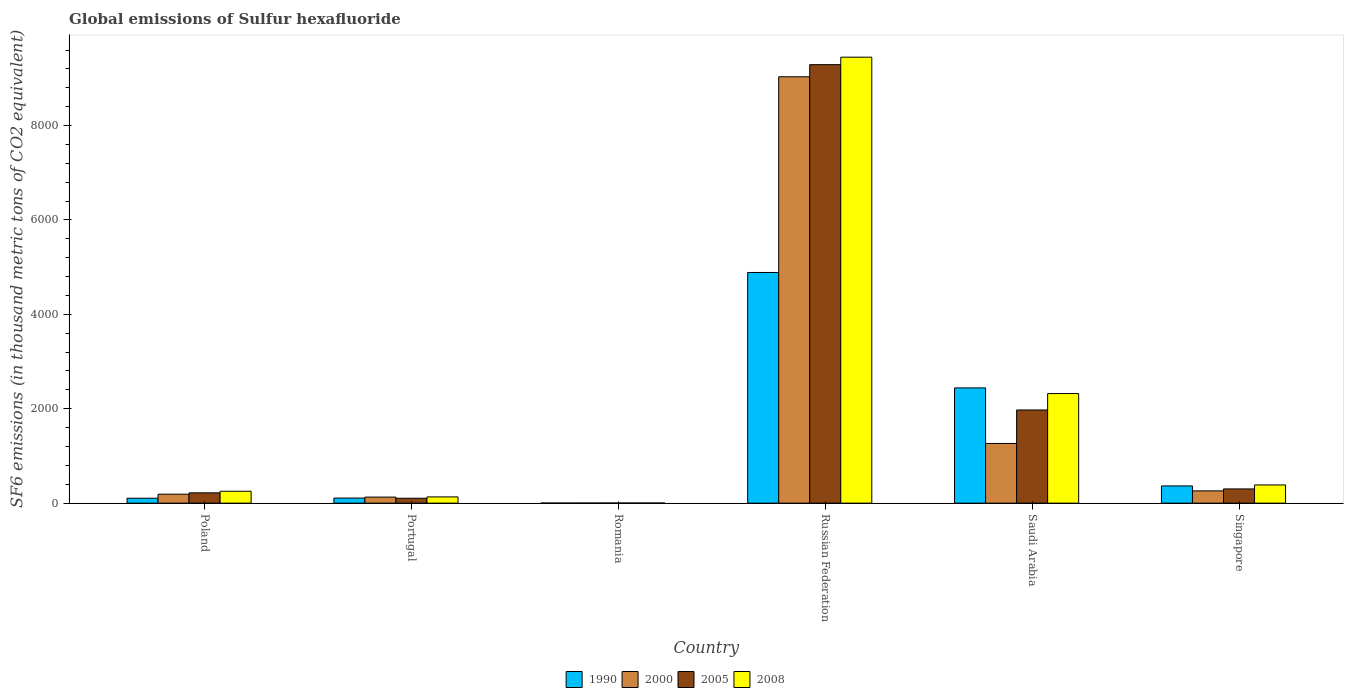How many different coloured bars are there?
Your answer should be very brief. 4. How many groups of bars are there?
Provide a short and direct response. 6. Are the number of bars per tick equal to the number of legend labels?
Ensure brevity in your answer.  Yes. Are the number of bars on each tick of the X-axis equal?
Make the answer very short. Yes. What is the label of the 4th group of bars from the left?
Offer a very short reply. Russian Federation. What is the global emissions of Sulfur hexafluoride in 2008 in Saudi Arabia?
Your response must be concise. 2321.8. Across all countries, what is the maximum global emissions of Sulfur hexafluoride in 1990?
Offer a terse response. 4886.8. In which country was the global emissions of Sulfur hexafluoride in 2008 maximum?
Your answer should be very brief. Russian Federation. In which country was the global emissions of Sulfur hexafluoride in 1990 minimum?
Your response must be concise. Romania. What is the total global emissions of Sulfur hexafluoride in 2008 in the graph?
Your response must be concise. 1.25e+04. What is the difference between the global emissions of Sulfur hexafluoride in 1990 in Poland and that in Romania?
Keep it short and to the point. 102.7. What is the difference between the global emissions of Sulfur hexafluoride in 2005 in Portugal and the global emissions of Sulfur hexafluoride in 1990 in Russian Federation?
Your answer should be compact. -4783. What is the average global emissions of Sulfur hexafluoride in 2005 per country?
Keep it short and to the point. 1981.57. What is the difference between the global emissions of Sulfur hexafluoride of/in 2008 and global emissions of Sulfur hexafluoride of/in 2005 in Poland?
Provide a short and direct response. 33.2. In how many countries, is the global emissions of Sulfur hexafluoride in 2008 greater than 800 thousand metric tons?
Your answer should be very brief. 2. What is the ratio of the global emissions of Sulfur hexafluoride in 2005 in Saudi Arabia to that in Singapore?
Give a very brief answer. 6.55. Is the global emissions of Sulfur hexafluoride in 2008 in Portugal less than that in Romania?
Your response must be concise. No. What is the difference between the highest and the second highest global emissions of Sulfur hexafluoride in 2000?
Keep it short and to the point. -7768.6. What is the difference between the highest and the lowest global emissions of Sulfur hexafluoride in 2008?
Make the answer very short. 9445.9. What does the 1st bar from the left in Romania represents?
Ensure brevity in your answer.  1990. What does the 4th bar from the right in Portugal represents?
Provide a succinct answer. 1990. Is it the case that in every country, the sum of the global emissions of Sulfur hexafluoride in 2008 and global emissions of Sulfur hexafluoride in 2000 is greater than the global emissions of Sulfur hexafluoride in 2005?
Offer a very short reply. Yes. How many bars are there?
Offer a terse response. 24. How many countries are there in the graph?
Give a very brief answer. 6. Does the graph contain any zero values?
Offer a very short reply. No. Where does the legend appear in the graph?
Offer a very short reply. Bottom center. How many legend labels are there?
Your answer should be very brief. 4. What is the title of the graph?
Give a very brief answer. Global emissions of Sulfur hexafluoride. Does "1996" appear as one of the legend labels in the graph?
Your answer should be very brief. No. What is the label or title of the X-axis?
Your response must be concise. Country. What is the label or title of the Y-axis?
Your answer should be compact. SF6 emissions (in thousand metric tons of CO2 equivalent). What is the SF6 emissions (in thousand metric tons of CO2 equivalent) of 1990 in Poland?
Offer a very short reply. 104.3. What is the SF6 emissions (in thousand metric tons of CO2 equivalent) of 2000 in Poland?
Your response must be concise. 189.8. What is the SF6 emissions (in thousand metric tons of CO2 equivalent) in 2005 in Poland?
Keep it short and to the point. 218.5. What is the SF6 emissions (in thousand metric tons of CO2 equivalent) in 2008 in Poland?
Provide a succinct answer. 251.7. What is the SF6 emissions (in thousand metric tons of CO2 equivalent) in 1990 in Portugal?
Your response must be concise. 108. What is the SF6 emissions (in thousand metric tons of CO2 equivalent) in 2000 in Portugal?
Offer a terse response. 128. What is the SF6 emissions (in thousand metric tons of CO2 equivalent) of 2005 in Portugal?
Your answer should be very brief. 103.8. What is the SF6 emissions (in thousand metric tons of CO2 equivalent) in 2008 in Portugal?
Make the answer very short. 132.4. What is the SF6 emissions (in thousand metric tons of CO2 equivalent) of 2000 in Romania?
Offer a very short reply. 2. What is the SF6 emissions (in thousand metric tons of CO2 equivalent) in 2005 in Romania?
Your response must be concise. 2.2. What is the SF6 emissions (in thousand metric tons of CO2 equivalent) in 1990 in Russian Federation?
Your answer should be very brief. 4886.8. What is the SF6 emissions (in thousand metric tons of CO2 equivalent) of 2000 in Russian Federation?
Provide a succinct answer. 9033.2. What is the SF6 emissions (in thousand metric tons of CO2 equivalent) of 2005 in Russian Federation?
Keep it short and to the point. 9289.9. What is the SF6 emissions (in thousand metric tons of CO2 equivalent) of 2008 in Russian Federation?
Your answer should be very brief. 9448.2. What is the SF6 emissions (in thousand metric tons of CO2 equivalent) of 1990 in Saudi Arabia?
Offer a very short reply. 2441.3. What is the SF6 emissions (in thousand metric tons of CO2 equivalent) of 2000 in Saudi Arabia?
Your answer should be compact. 1264.6. What is the SF6 emissions (in thousand metric tons of CO2 equivalent) in 2005 in Saudi Arabia?
Provide a succinct answer. 1973.8. What is the SF6 emissions (in thousand metric tons of CO2 equivalent) of 2008 in Saudi Arabia?
Your answer should be very brief. 2321.8. What is the SF6 emissions (in thousand metric tons of CO2 equivalent) of 1990 in Singapore?
Give a very brief answer. 364.7. What is the SF6 emissions (in thousand metric tons of CO2 equivalent) of 2000 in Singapore?
Provide a short and direct response. 259.8. What is the SF6 emissions (in thousand metric tons of CO2 equivalent) of 2005 in Singapore?
Provide a succinct answer. 301.2. What is the SF6 emissions (in thousand metric tons of CO2 equivalent) in 2008 in Singapore?
Ensure brevity in your answer.  385.5. Across all countries, what is the maximum SF6 emissions (in thousand metric tons of CO2 equivalent) of 1990?
Your answer should be compact. 4886.8. Across all countries, what is the maximum SF6 emissions (in thousand metric tons of CO2 equivalent) in 2000?
Your response must be concise. 9033.2. Across all countries, what is the maximum SF6 emissions (in thousand metric tons of CO2 equivalent) in 2005?
Give a very brief answer. 9289.9. Across all countries, what is the maximum SF6 emissions (in thousand metric tons of CO2 equivalent) of 2008?
Your response must be concise. 9448.2. Across all countries, what is the minimum SF6 emissions (in thousand metric tons of CO2 equivalent) in 1990?
Provide a succinct answer. 1.6. Across all countries, what is the minimum SF6 emissions (in thousand metric tons of CO2 equivalent) of 2005?
Offer a very short reply. 2.2. What is the total SF6 emissions (in thousand metric tons of CO2 equivalent) in 1990 in the graph?
Offer a very short reply. 7906.7. What is the total SF6 emissions (in thousand metric tons of CO2 equivalent) in 2000 in the graph?
Make the answer very short. 1.09e+04. What is the total SF6 emissions (in thousand metric tons of CO2 equivalent) in 2005 in the graph?
Offer a very short reply. 1.19e+04. What is the total SF6 emissions (in thousand metric tons of CO2 equivalent) of 2008 in the graph?
Offer a terse response. 1.25e+04. What is the difference between the SF6 emissions (in thousand metric tons of CO2 equivalent) of 1990 in Poland and that in Portugal?
Your answer should be very brief. -3.7. What is the difference between the SF6 emissions (in thousand metric tons of CO2 equivalent) in 2000 in Poland and that in Portugal?
Offer a very short reply. 61.8. What is the difference between the SF6 emissions (in thousand metric tons of CO2 equivalent) of 2005 in Poland and that in Portugal?
Make the answer very short. 114.7. What is the difference between the SF6 emissions (in thousand metric tons of CO2 equivalent) in 2008 in Poland and that in Portugal?
Give a very brief answer. 119.3. What is the difference between the SF6 emissions (in thousand metric tons of CO2 equivalent) of 1990 in Poland and that in Romania?
Offer a terse response. 102.7. What is the difference between the SF6 emissions (in thousand metric tons of CO2 equivalent) in 2000 in Poland and that in Romania?
Your answer should be compact. 187.8. What is the difference between the SF6 emissions (in thousand metric tons of CO2 equivalent) in 2005 in Poland and that in Romania?
Make the answer very short. 216.3. What is the difference between the SF6 emissions (in thousand metric tons of CO2 equivalent) in 2008 in Poland and that in Romania?
Your answer should be very brief. 249.4. What is the difference between the SF6 emissions (in thousand metric tons of CO2 equivalent) of 1990 in Poland and that in Russian Federation?
Give a very brief answer. -4782.5. What is the difference between the SF6 emissions (in thousand metric tons of CO2 equivalent) of 2000 in Poland and that in Russian Federation?
Provide a short and direct response. -8843.4. What is the difference between the SF6 emissions (in thousand metric tons of CO2 equivalent) of 2005 in Poland and that in Russian Federation?
Make the answer very short. -9071.4. What is the difference between the SF6 emissions (in thousand metric tons of CO2 equivalent) in 2008 in Poland and that in Russian Federation?
Ensure brevity in your answer.  -9196.5. What is the difference between the SF6 emissions (in thousand metric tons of CO2 equivalent) of 1990 in Poland and that in Saudi Arabia?
Ensure brevity in your answer.  -2337. What is the difference between the SF6 emissions (in thousand metric tons of CO2 equivalent) in 2000 in Poland and that in Saudi Arabia?
Your response must be concise. -1074.8. What is the difference between the SF6 emissions (in thousand metric tons of CO2 equivalent) of 2005 in Poland and that in Saudi Arabia?
Offer a terse response. -1755.3. What is the difference between the SF6 emissions (in thousand metric tons of CO2 equivalent) of 2008 in Poland and that in Saudi Arabia?
Keep it short and to the point. -2070.1. What is the difference between the SF6 emissions (in thousand metric tons of CO2 equivalent) in 1990 in Poland and that in Singapore?
Your response must be concise. -260.4. What is the difference between the SF6 emissions (in thousand metric tons of CO2 equivalent) of 2000 in Poland and that in Singapore?
Your answer should be very brief. -70. What is the difference between the SF6 emissions (in thousand metric tons of CO2 equivalent) of 2005 in Poland and that in Singapore?
Your response must be concise. -82.7. What is the difference between the SF6 emissions (in thousand metric tons of CO2 equivalent) in 2008 in Poland and that in Singapore?
Ensure brevity in your answer.  -133.8. What is the difference between the SF6 emissions (in thousand metric tons of CO2 equivalent) of 1990 in Portugal and that in Romania?
Provide a succinct answer. 106.4. What is the difference between the SF6 emissions (in thousand metric tons of CO2 equivalent) in 2000 in Portugal and that in Romania?
Provide a short and direct response. 126. What is the difference between the SF6 emissions (in thousand metric tons of CO2 equivalent) in 2005 in Portugal and that in Romania?
Keep it short and to the point. 101.6. What is the difference between the SF6 emissions (in thousand metric tons of CO2 equivalent) of 2008 in Portugal and that in Romania?
Offer a very short reply. 130.1. What is the difference between the SF6 emissions (in thousand metric tons of CO2 equivalent) in 1990 in Portugal and that in Russian Federation?
Ensure brevity in your answer.  -4778.8. What is the difference between the SF6 emissions (in thousand metric tons of CO2 equivalent) of 2000 in Portugal and that in Russian Federation?
Ensure brevity in your answer.  -8905.2. What is the difference between the SF6 emissions (in thousand metric tons of CO2 equivalent) of 2005 in Portugal and that in Russian Federation?
Provide a short and direct response. -9186.1. What is the difference between the SF6 emissions (in thousand metric tons of CO2 equivalent) of 2008 in Portugal and that in Russian Federation?
Ensure brevity in your answer.  -9315.8. What is the difference between the SF6 emissions (in thousand metric tons of CO2 equivalent) in 1990 in Portugal and that in Saudi Arabia?
Offer a very short reply. -2333.3. What is the difference between the SF6 emissions (in thousand metric tons of CO2 equivalent) in 2000 in Portugal and that in Saudi Arabia?
Give a very brief answer. -1136.6. What is the difference between the SF6 emissions (in thousand metric tons of CO2 equivalent) in 2005 in Portugal and that in Saudi Arabia?
Make the answer very short. -1870. What is the difference between the SF6 emissions (in thousand metric tons of CO2 equivalent) of 2008 in Portugal and that in Saudi Arabia?
Offer a very short reply. -2189.4. What is the difference between the SF6 emissions (in thousand metric tons of CO2 equivalent) in 1990 in Portugal and that in Singapore?
Your answer should be very brief. -256.7. What is the difference between the SF6 emissions (in thousand metric tons of CO2 equivalent) of 2000 in Portugal and that in Singapore?
Your response must be concise. -131.8. What is the difference between the SF6 emissions (in thousand metric tons of CO2 equivalent) of 2005 in Portugal and that in Singapore?
Provide a short and direct response. -197.4. What is the difference between the SF6 emissions (in thousand metric tons of CO2 equivalent) of 2008 in Portugal and that in Singapore?
Keep it short and to the point. -253.1. What is the difference between the SF6 emissions (in thousand metric tons of CO2 equivalent) in 1990 in Romania and that in Russian Federation?
Provide a succinct answer. -4885.2. What is the difference between the SF6 emissions (in thousand metric tons of CO2 equivalent) in 2000 in Romania and that in Russian Federation?
Provide a succinct answer. -9031.2. What is the difference between the SF6 emissions (in thousand metric tons of CO2 equivalent) in 2005 in Romania and that in Russian Federation?
Provide a short and direct response. -9287.7. What is the difference between the SF6 emissions (in thousand metric tons of CO2 equivalent) of 2008 in Romania and that in Russian Federation?
Offer a terse response. -9445.9. What is the difference between the SF6 emissions (in thousand metric tons of CO2 equivalent) in 1990 in Romania and that in Saudi Arabia?
Make the answer very short. -2439.7. What is the difference between the SF6 emissions (in thousand metric tons of CO2 equivalent) of 2000 in Romania and that in Saudi Arabia?
Give a very brief answer. -1262.6. What is the difference between the SF6 emissions (in thousand metric tons of CO2 equivalent) of 2005 in Romania and that in Saudi Arabia?
Your answer should be very brief. -1971.6. What is the difference between the SF6 emissions (in thousand metric tons of CO2 equivalent) in 2008 in Romania and that in Saudi Arabia?
Offer a terse response. -2319.5. What is the difference between the SF6 emissions (in thousand metric tons of CO2 equivalent) in 1990 in Romania and that in Singapore?
Your answer should be compact. -363.1. What is the difference between the SF6 emissions (in thousand metric tons of CO2 equivalent) in 2000 in Romania and that in Singapore?
Provide a succinct answer. -257.8. What is the difference between the SF6 emissions (in thousand metric tons of CO2 equivalent) of 2005 in Romania and that in Singapore?
Provide a short and direct response. -299. What is the difference between the SF6 emissions (in thousand metric tons of CO2 equivalent) of 2008 in Romania and that in Singapore?
Ensure brevity in your answer.  -383.2. What is the difference between the SF6 emissions (in thousand metric tons of CO2 equivalent) of 1990 in Russian Federation and that in Saudi Arabia?
Your answer should be very brief. 2445.5. What is the difference between the SF6 emissions (in thousand metric tons of CO2 equivalent) of 2000 in Russian Federation and that in Saudi Arabia?
Ensure brevity in your answer.  7768.6. What is the difference between the SF6 emissions (in thousand metric tons of CO2 equivalent) of 2005 in Russian Federation and that in Saudi Arabia?
Offer a terse response. 7316.1. What is the difference between the SF6 emissions (in thousand metric tons of CO2 equivalent) in 2008 in Russian Federation and that in Saudi Arabia?
Provide a succinct answer. 7126.4. What is the difference between the SF6 emissions (in thousand metric tons of CO2 equivalent) in 1990 in Russian Federation and that in Singapore?
Provide a short and direct response. 4522.1. What is the difference between the SF6 emissions (in thousand metric tons of CO2 equivalent) of 2000 in Russian Federation and that in Singapore?
Make the answer very short. 8773.4. What is the difference between the SF6 emissions (in thousand metric tons of CO2 equivalent) in 2005 in Russian Federation and that in Singapore?
Ensure brevity in your answer.  8988.7. What is the difference between the SF6 emissions (in thousand metric tons of CO2 equivalent) in 2008 in Russian Federation and that in Singapore?
Offer a terse response. 9062.7. What is the difference between the SF6 emissions (in thousand metric tons of CO2 equivalent) of 1990 in Saudi Arabia and that in Singapore?
Provide a short and direct response. 2076.6. What is the difference between the SF6 emissions (in thousand metric tons of CO2 equivalent) of 2000 in Saudi Arabia and that in Singapore?
Offer a terse response. 1004.8. What is the difference between the SF6 emissions (in thousand metric tons of CO2 equivalent) in 2005 in Saudi Arabia and that in Singapore?
Your response must be concise. 1672.6. What is the difference between the SF6 emissions (in thousand metric tons of CO2 equivalent) of 2008 in Saudi Arabia and that in Singapore?
Provide a short and direct response. 1936.3. What is the difference between the SF6 emissions (in thousand metric tons of CO2 equivalent) in 1990 in Poland and the SF6 emissions (in thousand metric tons of CO2 equivalent) in 2000 in Portugal?
Offer a very short reply. -23.7. What is the difference between the SF6 emissions (in thousand metric tons of CO2 equivalent) in 1990 in Poland and the SF6 emissions (in thousand metric tons of CO2 equivalent) in 2005 in Portugal?
Make the answer very short. 0.5. What is the difference between the SF6 emissions (in thousand metric tons of CO2 equivalent) in 1990 in Poland and the SF6 emissions (in thousand metric tons of CO2 equivalent) in 2008 in Portugal?
Ensure brevity in your answer.  -28.1. What is the difference between the SF6 emissions (in thousand metric tons of CO2 equivalent) in 2000 in Poland and the SF6 emissions (in thousand metric tons of CO2 equivalent) in 2008 in Portugal?
Make the answer very short. 57.4. What is the difference between the SF6 emissions (in thousand metric tons of CO2 equivalent) of 2005 in Poland and the SF6 emissions (in thousand metric tons of CO2 equivalent) of 2008 in Portugal?
Your response must be concise. 86.1. What is the difference between the SF6 emissions (in thousand metric tons of CO2 equivalent) in 1990 in Poland and the SF6 emissions (in thousand metric tons of CO2 equivalent) in 2000 in Romania?
Offer a very short reply. 102.3. What is the difference between the SF6 emissions (in thousand metric tons of CO2 equivalent) in 1990 in Poland and the SF6 emissions (in thousand metric tons of CO2 equivalent) in 2005 in Romania?
Ensure brevity in your answer.  102.1. What is the difference between the SF6 emissions (in thousand metric tons of CO2 equivalent) of 1990 in Poland and the SF6 emissions (in thousand metric tons of CO2 equivalent) of 2008 in Romania?
Keep it short and to the point. 102. What is the difference between the SF6 emissions (in thousand metric tons of CO2 equivalent) of 2000 in Poland and the SF6 emissions (in thousand metric tons of CO2 equivalent) of 2005 in Romania?
Provide a succinct answer. 187.6. What is the difference between the SF6 emissions (in thousand metric tons of CO2 equivalent) of 2000 in Poland and the SF6 emissions (in thousand metric tons of CO2 equivalent) of 2008 in Romania?
Your response must be concise. 187.5. What is the difference between the SF6 emissions (in thousand metric tons of CO2 equivalent) of 2005 in Poland and the SF6 emissions (in thousand metric tons of CO2 equivalent) of 2008 in Romania?
Provide a short and direct response. 216.2. What is the difference between the SF6 emissions (in thousand metric tons of CO2 equivalent) in 1990 in Poland and the SF6 emissions (in thousand metric tons of CO2 equivalent) in 2000 in Russian Federation?
Give a very brief answer. -8928.9. What is the difference between the SF6 emissions (in thousand metric tons of CO2 equivalent) of 1990 in Poland and the SF6 emissions (in thousand metric tons of CO2 equivalent) of 2005 in Russian Federation?
Provide a succinct answer. -9185.6. What is the difference between the SF6 emissions (in thousand metric tons of CO2 equivalent) of 1990 in Poland and the SF6 emissions (in thousand metric tons of CO2 equivalent) of 2008 in Russian Federation?
Your response must be concise. -9343.9. What is the difference between the SF6 emissions (in thousand metric tons of CO2 equivalent) of 2000 in Poland and the SF6 emissions (in thousand metric tons of CO2 equivalent) of 2005 in Russian Federation?
Your answer should be compact. -9100.1. What is the difference between the SF6 emissions (in thousand metric tons of CO2 equivalent) in 2000 in Poland and the SF6 emissions (in thousand metric tons of CO2 equivalent) in 2008 in Russian Federation?
Provide a succinct answer. -9258.4. What is the difference between the SF6 emissions (in thousand metric tons of CO2 equivalent) in 2005 in Poland and the SF6 emissions (in thousand metric tons of CO2 equivalent) in 2008 in Russian Federation?
Provide a succinct answer. -9229.7. What is the difference between the SF6 emissions (in thousand metric tons of CO2 equivalent) in 1990 in Poland and the SF6 emissions (in thousand metric tons of CO2 equivalent) in 2000 in Saudi Arabia?
Offer a terse response. -1160.3. What is the difference between the SF6 emissions (in thousand metric tons of CO2 equivalent) in 1990 in Poland and the SF6 emissions (in thousand metric tons of CO2 equivalent) in 2005 in Saudi Arabia?
Make the answer very short. -1869.5. What is the difference between the SF6 emissions (in thousand metric tons of CO2 equivalent) of 1990 in Poland and the SF6 emissions (in thousand metric tons of CO2 equivalent) of 2008 in Saudi Arabia?
Give a very brief answer. -2217.5. What is the difference between the SF6 emissions (in thousand metric tons of CO2 equivalent) of 2000 in Poland and the SF6 emissions (in thousand metric tons of CO2 equivalent) of 2005 in Saudi Arabia?
Provide a succinct answer. -1784. What is the difference between the SF6 emissions (in thousand metric tons of CO2 equivalent) of 2000 in Poland and the SF6 emissions (in thousand metric tons of CO2 equivalent) of 2008 in Saudi Arabia?
Your response must be concise. -2132. What is the difference between the SF6 emissions (in thousand metric tons of CO2 equivalent) in 2005 in Poland and the SF6 emissions (in thousand metric tons of CO2 equivalent) in 2008 in Saudi Arabia?
Your answer should be very brief. -2103.3. What is the difference between the SF6 emissions (in thousand metric tons of CO2 equivalent) of 1990 in Poland and the SF6 emissions (in thousand metric tons of CO2 equivalent) of 2000 in Singapore?
Your answer should be compact. -155.5. What is the difference between the SF6 emissions (in thousand metric tons of CO2 equivalent) of 1990 in Poland and the SF6 emissions (in thousand metric tons of CO2 equivalent) of 2005 in Singapore?
Offer a terse response. -196.9. What is the difference between the SF6 emissions (in thousand metric tons of CO2 equivalent) in 1990 in Poland and the SF6 emissions (in thousand metric tons of CO2 equivalent) in 2008 in Singapore?
Keep it short and to the point. -281.2. What is the difference between the SF6 emissions (in thousand metric tons of CO2 equivalent) in 2000 in Poland and the SF6 emissions (in thousand metric tons of CO2 equivalent) in 2005 in Singapore?
Provide a short and direct response. -111.4. What is the difference between the SF6 emissions (in thousand metric tons of CO2 equivalent) of 2000 in Poland and the SF6 emissions (in thousand metric tons of CO2 equivalent) of 2008 in Singapore?
Your answer should be very brief. -195.7. What is the difference between the SF6 emissions (in thousand metric tons of CO2 equivalent) of 2005 in Poland and the SF6 emissions (in thousand metric tons of CO2 equivalent) of 2008 in Singapore?
Keep it short and to the point. -167. What is the difference between the SF6 emissions (in thousand metric tons of CO2 equivalent) of 1990 in Portugal and the SF6 emissions (in thousand metric tons of CO2 equivalent) of 2000 in Romania?
Offer a very short reply. 106. What is the difference between the SF6 emissions (in thousand metric tons of CO2 equivalent) in 1990 in Portugal and the SF6 emissions (in thousand metric tons of CO2 equivalent) in 2005 in Romania?
Your answer should be compact. 105.8. What is the difference between the SF6 emissions (in thousand metric tons of CO2 equivalent) of 1990 in Portugal and the SF6 emissions (in thousand metric tons of CO2 equivalent) of 2008 in Romania?
Your response must be concise. 105.7. What is the difference between the SF6 emissions (in thousand metric tons of CO2 equivalent) of 2000 in Portugal and the SF6 emissions (in thousand metric tons of CO2 equivalent) of 2005 in Romania?
Ensure brevity in your answer.  125.8. What is the difference between the SF6 emissions (in thousand metric tons of CO2 equivalent) in 2000 in Portugal and the SF6 emissions (in thousand metric tons of CO2 equivalent) in 2008 in Romania?
Your answer should be compact. 125.7. What is the difference between the SF6 emissions (in thousand metric tons of CO2 equivalent) of 2005 in Portugal and the SF6 emissions (in thousand metric tons of CO2 equivalent) of 2008 in Romania?
Give a very brief answer. 101.5. What is the difference between the SF6 emissions (in thousand metric tons of CO2 equivalent) in 1990 in Portugal and the SF6 emissions (in thousand metric tons of CO2 equivalent) in 2000 in Russian Federation?
Ensure brevity in your answer.  -8925.2. What is the difference between the SF6 emissions (in thousand metric tons of CO2 equivalent) in 1990 in Portugal and the SF6 emissions (in thousand metric tons of CO2 equivalent) in 2005 in Russian Federation?
Your answer should be very brief. -9181.9. What is the difference between the SF6 emissions (in thousand metric tons of CO2 equivalent) of 1990 in Portugal and the SF6 emissions (in thousand metric tons of CO2 equivalent) of 2008 in Russian Federation?
Provide a short and direct response. -9340.2. What is the difference between the SF6 emissions (in thousand metric tons of CO2 equivalent) of 2000 in Portugal and the SF6 emissions (in thousand metric tons of CO2 equivalent) of 2005 in Russian Federation?
Your answer should be very brief. -9161.9. What is the difference between the SF6 emissions (in thousand metric tons of CO2 equivalent) of 2000 in Portugal and the SF6 emissions (in thousand metric tons of CO2 equivalent) of 2008 in Russian Federation?
Ensure brevity in your answer.  -9320.2. What is the difference between the SF6 emissions (in thousand metric tons of CO2 equivalent) of 2005 in Portugal and the SF6 emissions (in thousand metric tons of CO2 equivalent) of 2008 in Russian Federation?
Give a very brief answer. -9344.4. What is the difference between the SF6 emissions (in thousand metric tons of CO2 equivalent) in 1990 in Portugal and the SF6 emissions (in thousand metric tons of CO2 equivalent) in 2000 in Saudi Arabia?
Your answer should be very brief. -1156.6. What is the difference between the SF6 emissions (in thousand metric tons of CO2 equivalent) in 1990 in Portugal and the SF6 emissions (in thousand metric tons of CO2 equivalent) in 2005 in Saudi Arabia?
Your response must be concise. -1865.8. What is the difference between the SF6 emissions (in thousand metric tons of CO2 equivalent) of 1990 in Portugal and the SF6 emissions (in thousand metric tons of CO2 equivalent) of 2008 in Saudi Arabia?
Give a very brief answer. -2213.8. What is the difference between the SF6 emissions (in thousand metric tons of CO2 equivalent) of 2000 in Portugal and the SF6 emissions (in thousand metric tons of CO2 equivalent) of 2005 in Saudi Arabia?
Provide a short and direct response. -1845.8. What is the difference between the SF6 emissions (in thousand metric tons of CO2 equivalent) in 2000 in Portugal and the SF6 emissions (in thousand metric tons of CO2 equivalent) in 2008 in Saudi Arabia?
Offer a terse response. -2193.8. What is the difference between the SF6 emissions (in thousand metric tons of CO2 equivalent) of 2005 in Portugal and the SF6 emissions (in thousand metric tons of CO2 equivalent) of 2008 in Saudi Arabia?
Your response must be concise. -2218. What is the difference between the SF6 emissions (in thousand metric tons of CO2 equivalent) in 1990 in Portugal and the SF6 emissions (in thousand metric tons of CO2 equivalent) in 2000 in Singapore?
Provide a succinct answer. -151.8. What is the difference between the SF6 emissions (in thousand metric tons of CO2 equivalent) in 1990 in Portugal and the SF6 emissions (in thousand metric tons of CO2 equivalent) in 2005 in Singapore?
Your answer should be compact. -193.2. What is the difference between the SF6 emissions (in thousand metric tons of CO2 equivalent) in 1990 in Portugal and the SF6 emissions (in thousand metric tons of CO2 equivalent) in 2008 in Singapore?
Your answer should be very brief. -277.5. What is the difference between the SF6 emissions (in thousand metric tons of CO2 equivalent) of 2000 in Portugal and the SF6 emissions (in thousand metric tons of CO2 equivalent) of 2005 in Singapore?
Make the answer very short. -173.2. What is the difference between the SF6 emissions (in thousand metric tons of CO2 equivalent) in 2000 in Portugal and the SF6 emissions (in thousand metric tons of CO2 equivalent) in 2008 in Singapore?
Your answer should be compact. -257.5. What is the difference between the SF6 emissions (in thousand metric tons of CO2 equivalent) of 2005 in Portugal and the SF6 emissions (in thousand metric tons of CO2 equivalent) of 2008 in Singapore?
Ensure brevity in your answer.  -281.7. What is the difference between the SF6 emissions (in thousand metric tons of CO2 equivalent) of 1990 in Romania and the SF6 emissions (in thousand metric tons of CO2 equivalent) of 2000 in Russian Federation?
Provide a succinct answer. -9031.6. What is the difference between the SF6 emissions (in thousand metric tons of CO2 equivalent) in 1990 in Romania and the SF6 emissions (in thousand metric tons of CO2 equivalent) in 2005 in Russian Federation?
Offer a terse response. -9288.3. What is the difference between the SF6 emissions (in thousand metric tons of CO2 equivalent) in 1990 in Romania and the SF6 emissions (in thousand metric tons of CO2 equivalent) in 2008 in Russian Federation?
Ensure brevity in your answer.  -9446.6. What is the difference between the SF6 emissions (in thousand metric tons of CO2 equivalent) of 2000 in Romania and the SF6 emissions (in thousand metric tons of CO2 equivalent) of 2005 in Russian Federation?
Provide a short and direct response. -9287.9. What is the difference between the SF6 emissions (in thousand metric tons of CO2 equivalent) of 2000 in Romania and the SF6 emissions (in thousand metric tons of CO2 equivalent) of 2008 in Russian Federation?
Offer a terse response. -9446.2. What is the difference between the SF6 emissions (in thousand metric tons of CO2 equivalent) in 2005 in Romania and the SF6 emissions (in thousand metric tons of CO2 equivalent) in 2008 in Russian Federation?
Keep it short and to the point. -9446. What is the difference between the SF6 emissions (in thousand metric tons of CO2 equivalent) in 1990 in Romania and the SF6 emissions (in thousand metric tons of CO2 equivalent) in 2000 in Saudi Arabia?
Offer a very short reply. -1263. What is the difference between the SF6 emissions (in thousand metric tons of CO2 equivalent) in 1990 in Romania and the SF6 emissions (in thousand metric tons of CO2 equivalent) in 2005 in Saudi Arabia?
Offer a terse response. -1972.2. What is the difference between the SF6 emissions (in thousand metric tons of CO2 equivalent) in 1990 in Romania and the SF6 emissions (in thousand metric tons of CO2 equivalent) in 2008 in Saudi Arabia?
Give a very brief answer. -2320.2. What is the difference between the SF6 emissions (in thousand metric tons of CO2 equivalent) in 2000 in Romania and the SF6 emissions (in thousand metric tons of CO2 equivalent) in 2005 in Saudi Arabia?
Your answer should be compact. -1971.8. What is the difference between the SF6 emissions (in thousand metric tons of CO2 equivalent) in 2000 in Romania and the SF6 emissions (in thousand metric tons of CO2 equivalent) in 2008 in Saudi Arabia?
Provide a succinct answer. -2319.8. What is the difference between the SF6 emissions (in thousand metric tons of CO2 equivalent) of 2005 in Romania and the SF6 emissions (in thousand metric tons of CO2 equivalent) of 2008 in Saudi Arabia?
Make the answer very short. -2319.6. What is the difference between the SF6 emissions (in thousand metric tons of CO2 equivalent) of 1990 in Romania and the SF6 emissions (in thousand metric tons of CO2 equivalent) of 2000 in Singapore?
Provide a succinct answer. -258.2. What is the difference between the SF6 emissions (in thousand metric tons of CO2 equivalent) of 1990 in Romania and the SF6 emissions (in thousand metric tons of CO2 equivalent) of 2005 in Singapore?
Ensure brevity in your answer.  -299.6. What is the difference between the SF6 emissions (in thousand metric tons of CO2 equivalent) in 1990 in Romania and the SF6 emissions (in thousand metric tons of CO2 equivalent) in 2008 in Singapore?
Your response must be concise. -383.9. What is the difference between the SF6 emissions (in thousand metric tons of CO2 equivalent) in 2000 in Romania and the SF6 emissions (in thousand metric tons of CO2 equivalent) in 2005 in Singapore?
Provide a short and direct response. -299.2. What is the difference between the SF6 emissions (in thousand metric tons of CO2 equivalent) in 2000 in Romania and the SF6 emissions (in thousand metric tons of CO2 equivalent) in 2008 in Singapore?
Give a very brief answer. -383.5. What is the difference between the SF6 emissions (in thousand metric tons of CO2 equivalent) in 2005 in Romania and the SF6 emissions (in thousand metric tons of CO2 equivalent) in 2008 in Singapore?
Provide a short and direct response. -383.3. What is the difference between the SF6 emissions (in thousand metric tons of CO2 equivalent) of 1990 in Russian Federation and the SF6 emissions (in thousand metric tons of CO2 equivalent) of 2000 in Saudi Arabia?
Offer a terse response. 3622.2. What is the difference between the SF6 emissions (in thousand metric tons of CO2 equivalent) in 1990 in Russian Federation and the SF6 emissions (in thousand metric tons of CO2 equivalent) in 2005 in Saudi Arabia?
Make the answer very short. 2913. What is the difference between the SF6 emissions (in thousand metric tons of CO2 equivalent) in 1990 in Russian Federation and the SF6 emissions (in thousand metric tons of CO2 equivalent) in 2008 in Saudi Arabia?
Ensure brevity in your answer.  2565. What is the difference between the SF6 emissions (in thousand metric tons of CO2 equivalent) in 2000 in Russian Federation and the SF6 emissions (in thousand metric tons of CO2 equivalent) in 2005 in Saudi Arabia?
Give a very brief answer. 7059.4. What is the difference between the SF6 emissions (in thousand metric tons of CO2 equivalent) in 2000 in Russian Federation and the SF6 emissions (in thousand metric tons of CO2 equivalent) in 2008 in Saudi Arabia?
Ensure brevity in your answer.  6711.4. What is the difference between the SF6 emissions (in thousand metric tons of CO2 equivalent) in 2005 in Russian Federation and the SF6 emissions (in thousand metric tons of CO2 equivalent) in 2008 in Saudi Arabia?
Your response must be concise. 6968.1. What is the difference between the SF6 emissions (in thousand metric tons of CO2 equivalent) of 1990 in Russian Federation and the SF6 emissions (in thousand metric tons of CO2 equivalent) of 2000 in Singapore?
Your answer should be very brief. 4627. What is the difference between the SF6 emissions (in thousand metric tons of CO2 equivalent) of 1990 in Russian Federation and the SF6 emissions (in thousand metric tons of CO2 equivalent) of 2005 in Singapore?
Provide a succinct answer. 4585.6. What is the difference between the SF6 emissions (in thousand metric tons of CO2 equivalent) in 1990 in Russian Federation and the SF6 emissions (in thousand metric tons of CO2 equivalent) in 2008 in Singapore?
Offer a very short reply. 4501.3. What is the difference between the SF6 emissions (in thousand metric tons of CO2 equivalent) in 2000 in Russian Federation and the SF6 emissions (in thousand metric tons of CO2 equivalent) in 2005 in Singapore?
Make the answer very short. 8732. What is the difference between the SF6 emissions (in thousand metric tons of CO2 equivalent) in 2000 in Russian Federation and the SF6 emissions (in thousand metric tons of CO2 equivalent) in 2008 in Singapore?
Give a very brief answer. 8647.7. What is the difference between the SF6 emissions (in thousand metric tons of CO2 equivalent) of 2005 in Russian Federation and the SF6 emissions (in thousand metric tons of CO2 equivalent) of 2008 in Singapore?
Offer a terse response. 8904.4. What is the difference between the SF6 emissions (in thousand metric tons of CO2 equivalent) of 1990 in Saudi Arabia and the SF6 emissions (in thousand metric tons of CO2 equivalent) of 2000 in Singapore?
Your response must be concise. 2181.5. What is the difference between the SF6 emissions (in thousand metric tons of CO2 equivalent) of 1990 in Saudi Arabia and the SF6 emissions (in thousand metric tons of CO2 equivalent) of 2005 in Singapore?
Make the answer very short. 2140.1. What is the difference between the SF6 emissions (in thousand metric tons of CO2 equivalent) in 1990 in Saudi Arabia and the SF6 emissions (in thousand metric tons of CO2 equivalent) in 2008 in Singapore?
Your answer should be compact. 2055.8. What is the difference between the SF6 emissions (in thousand metric tons of CO2 equivalent) in 2000 in Saudi Arabia and the SF6 emissions (in thousand metric tons of CO2 equivalent) in 2005 in Singapore?
Ensure brevity in your answer.  963.4. What is the difference between the SF6 emissions (in thousand metric tons of CO2 equivalent) of 2000 in Saudi Arabia and the SF6 emissions (in thousand metric tons of CO2 equivalent) of 2008 in Singapore?
Your response must be concise. 879.1. What is the difference between the SF6 emissions (in thousand metric tons of CO2 equivalent) of 2005 in Saudi Arabia and the SF6 emissions (in thousand metric tons of CO2 equivalent) of 2008 in Singapore?
Offer a very short reply. 1588.3. What is the average SF6 emissions (in thousand metric tons of CO2 equivalent) in 1990 per country?
Ensure brevity in your answer.  1317.78. What is the average SF6 emissions (in thousand metric tons of CO2 equivalent) in 2000 per country?
Your answer should be very brief. 1812.9. What is the average SF6 emissions (in thousand metric tons of CO2 equivalent) in 2005 per country?
Provide a succinct answer. 1981.57. What is the average SF6 emissions (in thousand metric tons of CO2 equivalent) of 2008 per country?
Your answer should be very brief. 2090.32. What is the difference between the SF6 emissions (in thousand metric tons of CO2 equivalent) in 1990 and SF6 emissions (in thousand metric tons of CO2 equivalent) in 2000 in Poland?
Your answer should be compact. -85.5. What is the difference between the SF6 emissions (in thousand metric tons of CO2 equivalent) of 1990 and SF6 emissions (in thousand metric tons of CO2 equivalent) of 2005 in Poland?
Make the answer very short. -114.2. What is the difference between the SF6 emissions (in thousand metric tons of CO2 equivalent) of 1990 and SF6 emissions (in thousand metric tons of CO2 equivalent) of 2008 in Poland?
Your response must be concise. -147.4. What is the difference between the SF6 emissions (in thousand metric tons of CO2 equivalent) of 2000 and SF6 emissions (in thousand metric tons of CO2 equivalent) of 2005 in Poland?
Keep it short and to the point. -28.7. What is the difference between the SF6 emissions (in thousand metric tons of CO2 equivalent) of 2000 and SF6 emissions (in thousand metric tons of CO2 equivalent) of 2008 in Poland?
Provide a short and direct response. -61.9. What is the difference between the SF6 emissions (in thousand metric tons of CO2 equivalent) in 2005 and SF6 emissions (in thousand metric tons of CO2 equivalent) in 2008 in Poland?
Offer a very short reply. -33.2. What is the difference between the SF6 emissions (in thousand metric tons of CO2 equivalent) of 1990 and SF6 emissions (in thousand metric tons of CO2 equivalent) of 2005 in Portugal?
Ensure brevity in your answer.  4.2. What is the difference between the SF6 emissions (in thousand metric tons of CO2 equivalent) of 1990 and SF6 emissions (in thousand metric tons of CO2 equivalent) of 2008 in Portugal?
Ensure brevity in your answer.  -24.4. What is the difference between the SF6 emissions (in thousand metric tons of CO2 equivalent) in 2000 and SF6 emissions (in thousand metric tons of CO2 equivalent) in 2005 in Portugal?
Give a very brief answer. 24.2. What is the difference between the SF6 emissions (in thousand metric tons of CO2 equivalent) of 2005 and SF6 emissions (in thousand metric tons of CO2 equivalent) of 2008 in Portugal?
Provide a succinct answer. -28.6. What is the difference between the SF6 emissions (in thousand metric tons of CO2 equivalent) of 1990 and SF6 emissions (in thousand metric tons of CO2 equivalent) of 2008 in Romania?
Give a very brief answer. -0.7. What is the difference between the SF6 emissions (in thousand metric tons of CO2 equivalent) in 2000 and SF6 emissions (in thousand metric tons of CO2 equivalent) in 2008 in Romania?
Provide a short and direct response. -0.3. What is the difference between the SF6 emissions (in thousand metric tons of CO2 equivalent) in 1990 and SF6 emissions (in thousand metric tons of CO2 equivalent) in 2000 in Russian Federation?
Ensure brevity in your answer.  -4146.4. What is the difference between the SF6 emissions (in thousand metric tons of CO2 equivalent) in 1990 and SF6 emissions (in thousand metric tons of CO2 equivalent) in 2005 in Russian Federation?
Provide a short and direct response. -4403.1. What is the difference between the SF6 emissions (in thousand metric tons of CO2 equivalent) of 1990 and SF6 emissions (in thousand metric tons of CO2 equivalent) of 2008 in Russian Federation?
Your answer should be compact. -4561.4. What is the difference between the SF6 emissions (in thousand metric tons of CO2 equivalent) in 2000 and SF6 emissions (in thousand metric tons of CO2 equivalent) in 2005 in Russian Federation?
Ensure brevity in your answer.  -256.7. What is the difference between the SF6 emissions (in thousand metric tons of CO2 equivalent) of 2000 and SF6 emissions (in thousand metric tons of CO2 equivalent) of 2008 in Russian Federation?
Make the answer very short. -415. What is the difference between the SF6 emissions (in thousand metric tons of CO2 equivalent) in 2005 and SF6 emissions (in thousand metric tons of CO2 equivalent) in 2008 in Russian Federation?
Your response must be concise. -158.3. What is the difference between the SF6 emissions (in thousand metric tons of CO2 equivalent) in 1990 and SF6 emissions (in thousand metric tons of CO2 equivalent) in 2000 in Saudi Arabia?
Offer a very short reply. 1176.7. What is the difference between the SF6 emissions (in thousand metric tons of CO2 equivalent) of 1990 and SF6 emissions (in thousand metric tons of CO2 equivalent) of 2005 in Saudi Arabia?
Ensure brevity in your answer.  467.5. What is the difference between the SF6 emissions (in thousand metric tons of CO2 equivalent) of 1990 and SF6 emissions (in thousand metric tons of CO2 equivalent) of 2008 in Saudi Arabia?
Make the answer very short. 119.5. What is the difference between the SF6 emissions (in thousand metric tons of CO2 equivalent) of 2000 and SF6 emissions (in thousand metric tons of CO2 equivalent) of 2005 in Saudi Arabia?
Offer a terse response. -709.2. What is the difference between the SF6 emissions (in thousand metric tons of CO2 equivalent) in 2000 and SF6 emissions (in thousand metric tons of CO2 equivalent) in 2008 in Saudi Arabia?
Your answer should be compact. -1057.2. What is the difference between the SF6 emissions (in thousand metric tons of CO2 equivalent) of 2005 and SF6 emissions (in thousand metric tons of CO2 equivalent) of 2008 in Saudi Arabia?
Make the answer very short. -348. What is the difference between the SF6 emissions (in thousand metric tons of CO2 equivalent) of 1990 and SF6 emissions (in thousand metric tons of CO2 equivalent) of 2000 in Singapore?
Keep it short and to the point. 104.9. What is the difference between the SF6 emissions (in thousand metric tons of CO2 equivalent) in 1990 and SF6 emissions (in thousand metric tons of CO2 equivalent) in 2005 in Singapore?
Make the answer very short. 63.5. What is the difference between the SF6 emissions (in thousand metric tons of CO2 equivalent) of 1990 and SF6 emissions (in thousand metric tons of CO2 equivalent) of 2008 in Singapore?
Your answer should be compact. -20.8. What is the difference between the SF6 emissions (in thousand metric tons of CO2 equivalent) in 2000 and SF6 emissions (in thousand metric tons of CO2 equivalent) in 2005 in Singapore?
Your answer should be very brief. -41.4. What is the difference between the SF6 emissions (in thousand metric tons of CO2 equivalent) in 2000 and SF6 emissions (in thousand metric tons of CO2 equivalent) in 2008 in Singapore?
Provide a short and direct response. -125.7. What is the difference between the SF6 emissions (in thousand metric tons of CO2 equivalent) in 2005 and SF6 emissions (in thousand metric tons of CO2 equivalent) in 2008 in Singapore?
Ensure brevity in your answer.  -84.3. What is the ratio of the SF6 emissions (in thousand metric tons of CO2 equivalent) in 1990 in Poland to that in Portugal?
Give a very brief answer. 0.97. What is the ratio of the SF6 emissions (in thousand metric tons of CO2 equivalent) in 2000 in Poland to that in Portugal?
Your answer should be very brief. 1.48. What is the ratio of the SF6 emissions (in thousand metric tons of CO2 equivalent) in 2005 in Poland to that in Portugal?
Ensure brevity in your answer.  2.1. What is the ratio of the SF6 emissions (in thousand metric tons of CO2 equivalent) in 2008 in Poland to that in Portugal?
Provide a short and direct response. 1.9. What is the ratio of the SF6 emissions (in thousand metric tons of CO2 equivalent) in 1990 in Poland to that in Romania?
Offer a very short reply. 65.19. What is the ratio of the SF6 emissions (in thousand metric tons of CO2 equivalent) in 2000 in Poland to that in Romania?
Your answer should be compact. 94.9. What is the ratio of the SF6 emissions (in thousand metric tons of CO2 equivalent) of 2005 in Poland to that in Romania?
Give a very brief answer. 99.32. What is the ratio of the SF6 emissions (in thousand metric tons of CO2 equivalent) in 2008 in Poland to that in Romania?
Offer a terse response. 109.43. What is the ratio of the SF6 emissions (in thousand metric tons of CO2 equivalent) of 1990 in Poland to that in Russian Federation?
Provide a short and direct response. 0.02. What is the ratio of the SF6 emissions (in thousand metric tons of CO2 equivalent) in 2000 in Poland to that in Russian Federation?
Provide a succinct answer. 0.02. What is the ratio of the SF6 emissions (in thousand metric tons of CO2 equivalent) of 2005 in Poland to that in Russian Federation?
Provide a short and direct response. 0.02. What is the ratio of the SF6 emissions (in thousand metric tons of CO2 equivalent) in 2008 in Poland to that in Russian Federation?
Give a very brief answer. 0.03. What is the ratio of the SF6 emissions (in thousand metric tons of CO2 equivalent) in 1990 in Poland to that in Saudi Arabia?
Offer a very short reply. 0.04. What is the ratio of the SF6 emissions (in thousand metric tons of CO2 equivalent) in 2000 in Poland to that in Saudi Arabia?
Provide a short and direct response. 0.15. What is the ratio of the SF6 emissions (in thousand metric tons of CO2 equivalent) of 2005 in Poland to that in Saudi Arabia?
Offer a very short reply. 0.11. What is the ratio of the SF6 emissions (in thousand metric tons of CO2 equivalent) of 2008 in Poland to that in Saudi Arabia?
Offer a terse response. 0.11. What is the ratio of the SF6 emissions (in thousand metric tons of CO2 equivalent) in 1990 in Poland to that in Singapore?
Give a very brief answer. 0.29. What is the ratio of the SF6 emissions (in thousand metric tons of CO2 equivalent) in 2000 in Poland to that in Singapore?
Your answer should be compact. 0.73. What is the ratio of the SF6 emissions (in thousand metric tons of CO2 equivalent) in 2005 in Poland to that in Singapore?
Offer a terse response. 0.73. What is the ratio of the SF6 emissions (in thousand metric tons of CO2 equivalent) in 2008 in Poland to that in Singapore?
Offer a very short reply. 0.65. What is the ratio of the SF6 emissions (in thousand metric tons of CO2 equivalent) in 1990 in Portugal to that in Romania?
Make the answer very short. 67.5. What is the ratio of the SF6 emissions (in thousand metric tons of CO2 equivalent) of 2005 in Portugal to that in Romania?
Provide a short and direct response. 47.18. What is the ratio of the SF6 emissions (in thousand metric tons of CO2 equivalent) in 2008 in Portugal to that in Romania?
Provide a short and direct response. 57.57. What is the ratio of the SF6 emissions (in thousand metric tons of CO2 equivalent) in 1990 in Portugal to that in Russian Federation?
Your response must be concise. 0.02. What is the ratio of the SF6 emissions (in thousand metric tons of CO2 equivalent) in 2000 in Portugal to that in Russian Federation?
Your response must be concise. 0.01. What is the ratio of the SF6 emissions (in thousand metric tons of CO2 equivalent) in 2005 in Portugal to that in Russian Federation?
Provide a succinct answer. 0.01. What is the ratio of the SF6 emissions (in thousand metric tons of CO2 equivalent) of 2008 in Portugal to that in Russian Federation?
Keep it short and to the point. 0.01. What is the ratio of the SF6 emissions (in thousand metric tons of CO2 equivalent) of 1990 in Portugal to that in Saudi Arabia?
Provide a succinct answer. 0.04. What is the ratio of the SF6 emissions (in thousand metric tons of CO2 equivalent) in 2000 in Portugal to that in Saudi Arabia?
Provide a short and direct response. 0.1. What is the ratio of the SF6 emissions (in thousand metric tons of CO2 equivalent) of 2005 in Portugal to that in Saudi Arabia?
Ensure brevity in your answer.  0.05. What is the ratio of the SF6 emissions (in thousand metric tons of CO2 equivalent) of 2008 in Portugal to that in Saudi Arabia?
Provide a succinct answer. 0.06. What is the ratio of the SF6 emissions (in thousand metric tons of CO2 equivalent) in 1990 in Portugal to that in Singapore?
Ensure brevity in your answer.  0.3. What is the ratio of the SF6 emissions (in thousand metric tons of CO2 equivalent) of 2000 in Portugal to that in Singapore?
Your answer should be very brief. 0.49. What is the ratio of the SF6 emissions (in thousand metric tons of CO2 equivalent) in 2005 in Portugal to that in Singapore?
Your answer should be very brief. 0.34. What is the ratio of the SF6 emissions (in thousand metric tons of CO2 equivalent) of 2008 in Portugal to that in Singapore?
Offer a very short reply. 0.34. What is the ratio of the SF6 emissions (in thousand metric tons of CO2 equivalent) in 2000 in Romania to that in Russian Federation?
Provide a short and direct response. 0. What is the ratio of the SF6 emissions (in thousand metric tons of CO2 equivalent) in 2005 in Romania to that in Russian Federation?
Keep it short and to the point. 0. What is the ratio of the SF6 emissions (in thousand metric tons of CO2 equivalent) of 1990 in Romania to that in Saudi Arabia?
Your response must be concise. 0. What is the ratio of the SF6 emissions (in thousand metric tons of CO2 equivalent) in 2000 in Romania to that in Saudi Arabia?
Your answer should be compact. 0. What is the ratio of the SF6 emissions (in thousand metric tons of CO2 equivalent) of 2005 in Romania to that in Saudi Arabia?
Your answer should be compact. 0. What is the ratio of the SF6 emissions (in thousand metric tons of CO2 equivalent) of 2008 in Romania to that in Saudi Arabia?
Make the answer very short. 0. What is the ratio of the SF6 emissions (in thousand metric tons of CO2 equivalent) of 1990 in Romania to that in Singapore?
Give a very brief answer. 0. What is the ratio of the SF6 emissions (in thousand metric tons of CO2 equivalent) of 2000 in Romania to that in Singapore?
Your answer should be very brief. 0.01. What is the ratio of the SF6 emissions (in thousand metric tons of CO2 equivalent) in 2005 in Romania to that in Singapore?
Provide a succinct answer. 0.01. What is the ratio of the SF6 emissions (in thousand metric tons of CO2 equivalent) of 2008 in Romania to that in Singapore?
Offer a terse response. 0.01. What is the ratio of the SF6 emissions (in thousand metric tons of CO2 equivalent) of 1990 in Russian Federation to that in Saudi Arabia?
Provide a short and direct response. 2. What is the ratio of the SF6 emissions (in thousand metric tons of CO2 equivalent) of 2000 in Russian Federation to that in Saudi Arabia?
Make the answer very short. 7.14. What is the ratio of the SF6 emissions (in thousand metric tons of CO2 equivalent) in 2005 in Russian Federation to that in Saudi Arabia?
Offer a very short reply. 4.71. What is the ratio of the SF6 emissions (in thousand metric tons of CO2 equivalent) of 2008 in Russian Federation to that in Saudi Arabia?
Give a very brief answer. 4.07. What is the ratio of the SF6 emissions (in thousand metric tons of CO2 equivalent) in 1990 in Russian Federation to that in Singapore?
Your response must be concise. 13.4. What is the ratio of the SF6 emissions (in thousand metric tons of CO2 equivalent) of 2000 in Russian Federation to that in Singapore?
Your answer should be very brief. 34.77. What is the ratio of the SF6 emissions (in thousand metric tons of CO2 equivalent) of 2005 in Russian Federation to that in Singapore?
Ensure brevity in your answer.  30.84. What is the ratio of the SF6 emissions (in thousand metric tons of CO2 equivalent) in 2008 in Russian Federation to that in Singapore?
Make the answer very short. 24.51. What is the ratio of the SF6 emissions (in thousand metric tons of CO2 equivalent) of 1990 in Saudi Arabia to that in Singapore?
Provide a short and direct response. 6.69. What is the ratio of the SF6 emissions (in thousand metric tons of CO2 equivalent) in 2000 in Saudi Arabia to that in Singapore?
Your response must be concise. 4.87. What is the ratio of the SF6 emissions (in thousand metric tons of CO2 equivalent) of 2005 in Saudi Arabia to that in Singapore?
Provide a short and direct response. 6.55. What is the ratio of the SF6 emissions (in thousand metric tons of CO2 equivalent) of 2008 in Saudi Arabia to that in Singapore?
Your response must be concise. 6.02. What is the difference between the highest and the second highest SF6 emissions (in thousand metric tons of CO2 equivalent) in 1990?
Give a very brief answer. 2445.5. What is the difference between the highest and the second highest SF6 emissions (in thousand metric tons of CO2 equivalent) of 2000?
Offer a very short reply. 7768.6. What is the difference between the highest and the second highest SF6 emissions (in thousand metric tons of CO2 equivalent) in 2005?
Offer a very short reply. 7316.1. What is the difference between the highest and the second highest SF6 emissions (in thousand metric tons of CO2 equivalent) of 2008?
Your response must be concise. 7126.4. What is the difference between the highest and the lowest SF6 emissions (in thousand metric tons of CO2 equivalent) in 1990?
Offer a very short reply. 4885.2. What is the difference between the highest and the lowest SF6 emissions (in thousand metric tons of CO2 equivalent) in 2000?
Provide a short and direct response. 9031.2. What is the difference between the highest and the lowest SF6 emissions (in thousand metric tons of CO2 equivalent) of 2005?
Make the answer very short. 9287.7. What is the difference between the highest and the lowest SF6 emissions (in thousand metric tons of CO2 equivalent) in 2008?
Offer a terse response. 9445.9. 